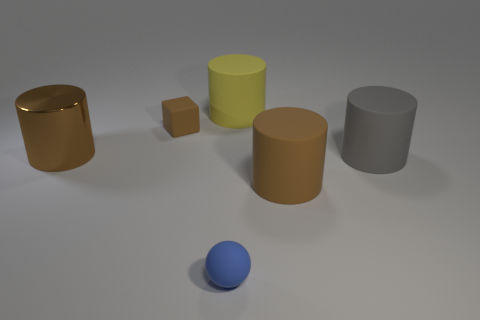Subtract all yellow matte cylinders. How many cylinders are left? 3 Add 4 rubber blocks. How many objects exist? 10 Subtract all yellow cylinders. How many cylinders are left? 3 Subtract all cubes. How many objects are left? 5 Subtract all cyan cubes. Subtract all yellow balls. How many cubes are left? 1 Subtract all gray cylinders. How many gray spheres are left? 0 Subtract all gray rubber cylinders. Subtract all small blue objects. How many objects are left? 4 Add 6 large shiny cylinders. How many large shiny cylinders are left? 7 Add 1 blue rubber balls. How many blue rubber balls exist? 2 Subtract 0 gray balls. How many objects are left? 6 